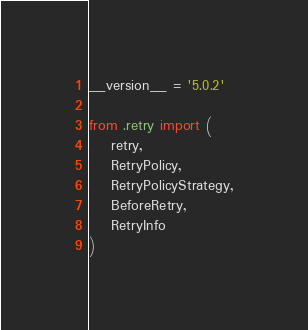Convert code to text. <code><loc_0><loc_0><loc_500><loc_500><_Python_>__version__ = '5.0.2'

from .retry import (
    retry,
    RetryPolicy,
    RetryPolicyStrategy,
    BeforeRetry,
    RetryInfo
)
</code> 